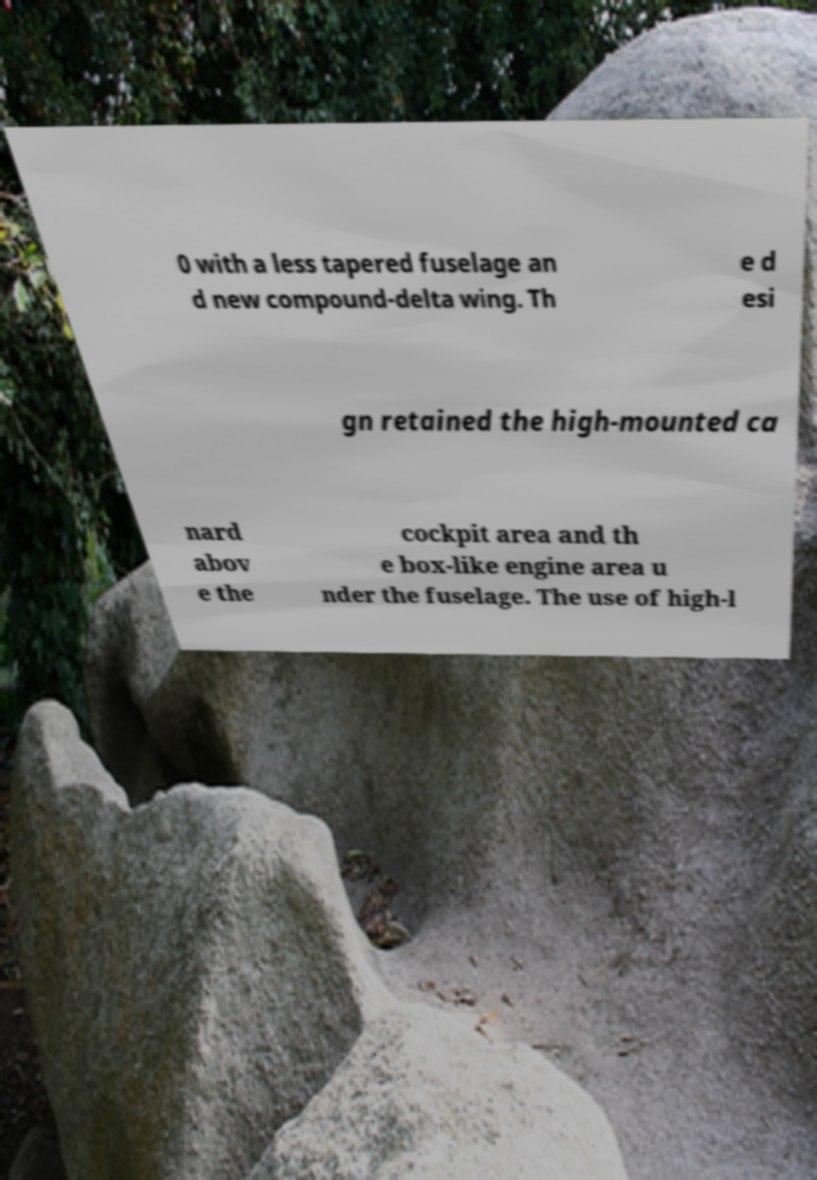Can you read and provide the text displayed in the image?This photo seems to have some interesting text. Can you extract and type it out for me? 0 with a less tapered fuselage an d new compound-delta wing. Th e d esi gn retained the high-mounted ca nard abov e the cockpit area and th e box-like engine area u nder the fuselage. The use of high-l 